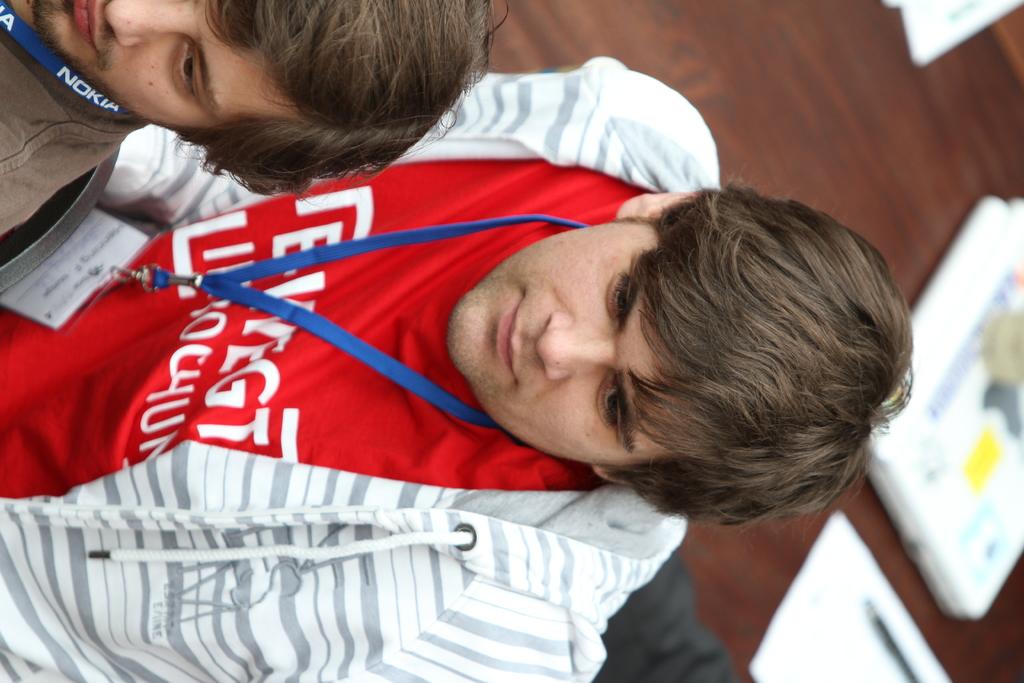What is the brand of lanyard on the boy in top corner?
Offer a very short reply. Nokia. 